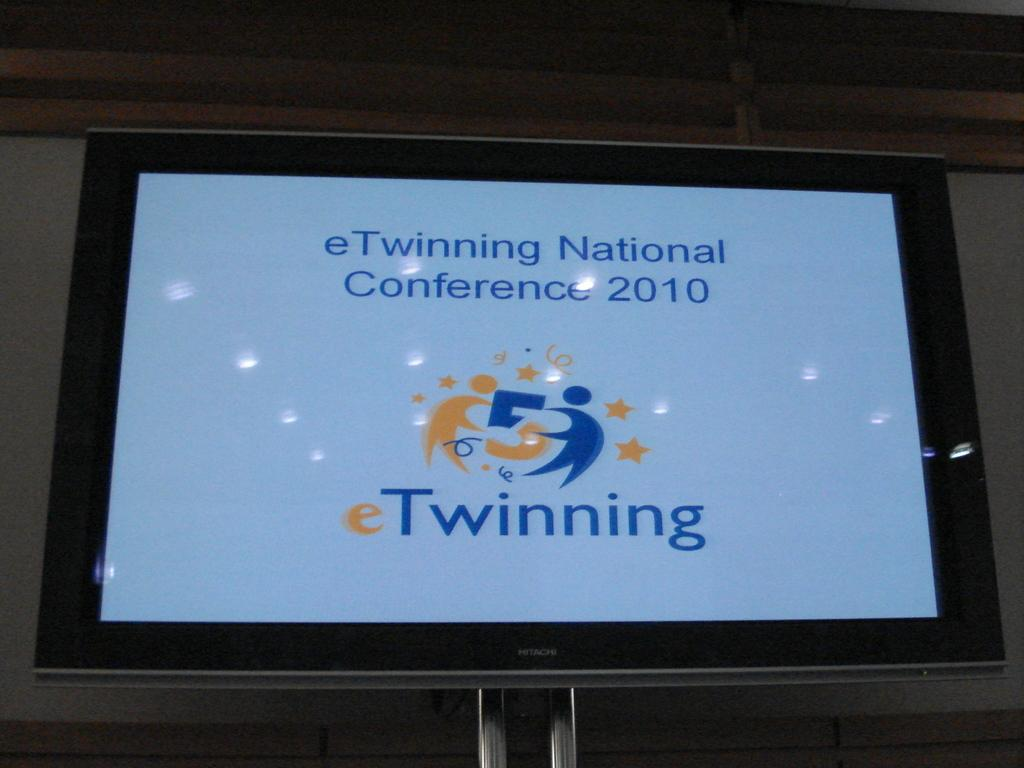<image>
Relay a brief, clear account of the picture shown. a television with the word Twinning at the bottom 